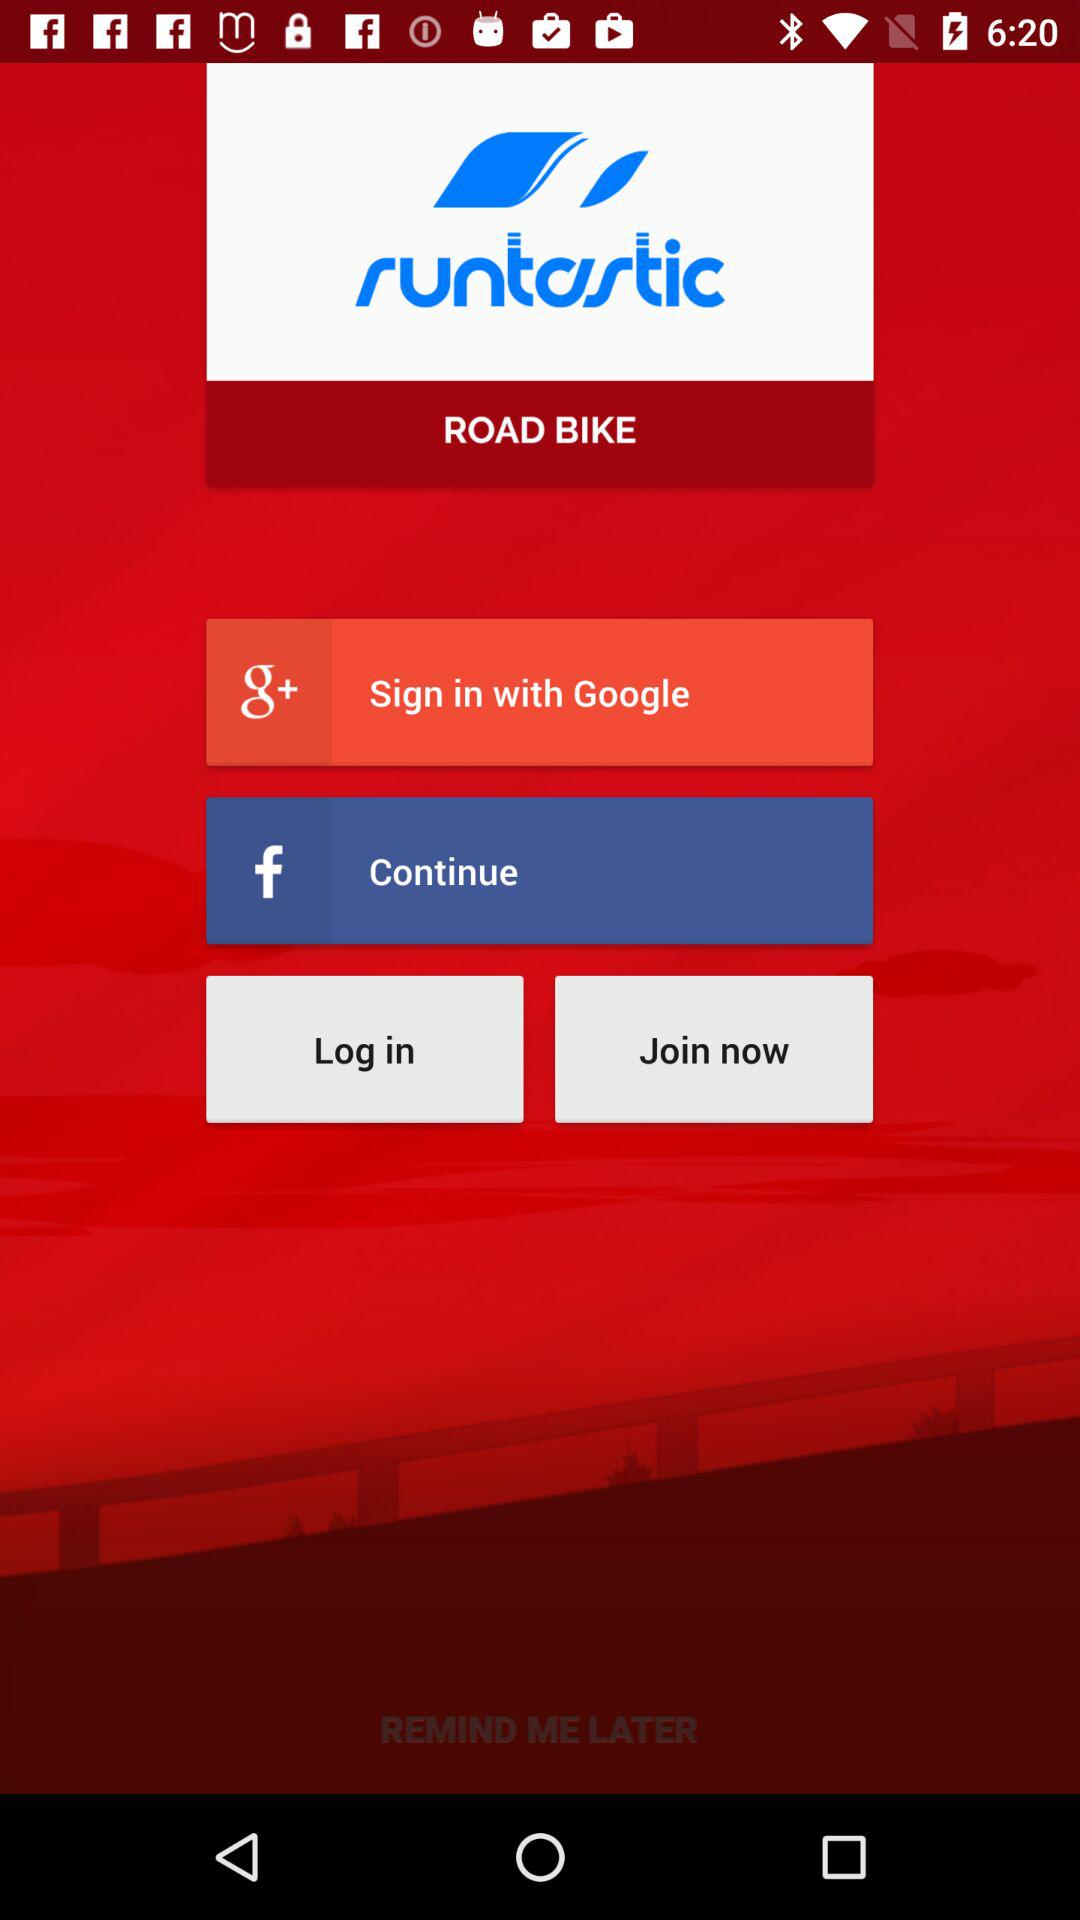What are the different options available for logging in? The different options available for logging in are "Google+" and "Facebook". 